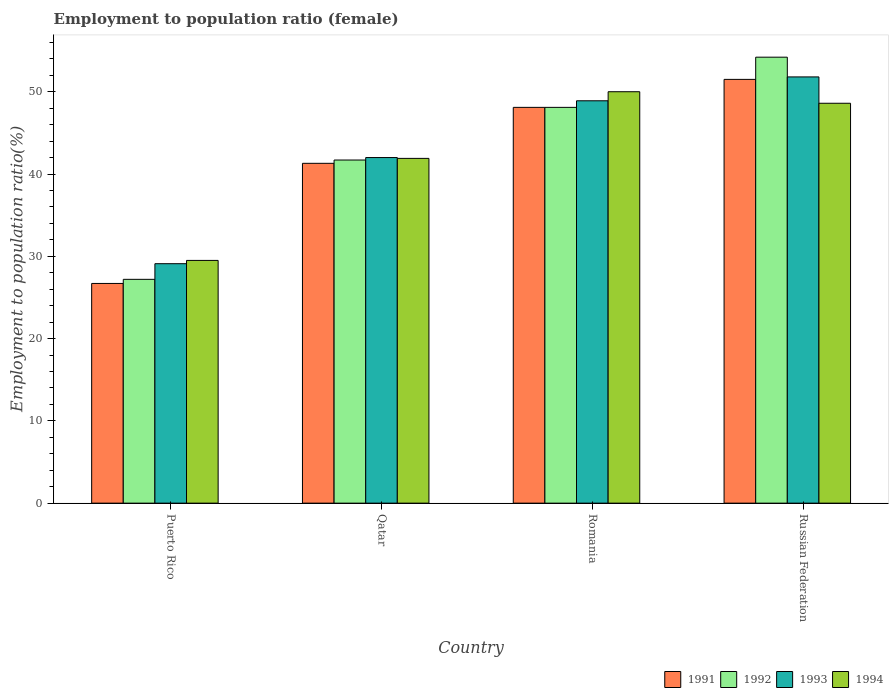How many groups of bars are there?
Your response must be concise. 4. Are the number of bars on each tick of the X-axis equal?
Ensure brevity in your answer.  Yes. How many bars are there on the 4th tick from the left?
Make the answer very short. 4. How many bars are there on the 1st tick from the right?
Offer a very short reply. 4. What is the label of the 2nd group of bars from the left?
Your answer should be compact. Qatar. What is the employment to population ratio in 1991 in Puerto Rico?
Keep it short and to the point. 26.7. Across all countries, what is the maximum employment to population ratio in 1991?
Offer a very short reply. 51.5. Across all countries, what is the minimum employment to population ratio in 1992?
Your answer should be very brief. 27.2. In which country was the employment to population ratio in 1994 maximum?
Offer a terse response. Romania. In which country was the employment to population ratio in 1994 minimum?
Your answer should be compact. Puerto Rico. What is the total employment to population ratio in 1992 in the graph?
Your response must be concise. 171.2. What is the difference between the employment to population ratio in 1991 in Romania and that in Russian Federation?
Provide a succinct answer. -3.4. What is the difference between the employment to population ratio in 1991 in Romania and the employment to population ratio in 1992 in Russian Federation?
Give a very brief answer. -6.1. What is the average employment to population ratio in 1992 per country?
Ensure brevity in your answer.  42.8. What is the difference between the employment to population ratio of/in 1994 and employment to population ratio of/in 1992 in Qatar?
Provide a succinct answer. 0.2. In how many countries, is the employment to population ratio in 1992 greater than 20 %?
Offer a terse response. 4. What is the ratio of the employment to population ratio in 1993 in Puerto Rico to that in Romania?
Offer a very short reply. 0.6. Is the employment to population ratio in 1993 in Puerto Rico less than that in Russian Federation?
Your answer should be very brief. Yes. Is the difference between the employment to population ratio in 1994 in Qatar and Russian Federation greater than the difference between the employment to population ratio in 1992 in Qatar and Russian Federation?
Offer a terse response. Yes. What is the difference between the highest and the second highest employment to population ratio in 1994?
Provide a succinct answer. 6.7. What is the difference between the highest and the lowest employment to population ratio in 1992?
Your answer should be very brief. 27. Is it the case that in every country, the sum of the employment to population ratio in 1991 and employment to population ratio in 1994 is greater than the sum of employment to population ratio in 1993 and employment to population ratio in 1992?
Your answer should be very brief. No. Is it the case that in every country, the sum of the employment to population ratio in 1994 and employment to population ratio in 1992 is greater than the employment to population ratio in 1991?
Keep it short and to the point. Yes. Are all the bars in the graph horizontal?
Your answer should be compact. No. What is the difference between two consecutive major ticks on the Y-axis?
Make the answer very short. 10. Does the graph contain grids?
Keep it short and to the point. No. Where does the legend appear in the graph?
Offer a very short reply. Bottom right. How many legend labels are there?
Keep it short and to the point. 4. How are the legend labels stacked?
Offer a very short reply. Horizontal. What is the title of the graph?
Provide a succinct answer. Employment to population ratio (female). Does "1960" appear as one of the legend labels in the graph?
Your answer should be compact. No. What is the Employment to population ratio(%) in 1991 in Puerto Rico?
Your response must be concise. 26.7. What is the Employment to population ratio(%) of 1992 in Puerto Rico?
Your response must be concise. 27.2. What is the Employment to population ratio(%) of 1993 in Puerto Rico?
Offer a terse response. 29.1. What is the Employment to population ratio(%) in 1994 in Puerto Rico?
Provide a short and direct response. 29.5. What is the Employment to population ratio(%) in 1991 in Qatar?
Keep it short and to the point. 41.3. What is the Employment to population ratio(%) in 1992 in Qatar?
Your response must be concise. 41.7. What is the Employment to population ratio(%) of 1994 in Qatar?
Keep it short and to the point. 41.9. What is the Employment to population ratio(%) in 1991 in Romania?
Your answer should be very brief. 48.1. What is the Employment to population ratio(%) of 1992 in Romania?
Give a very brief answer. 48.1. What is the Employment to population ratio(%) in 1993 in Romania?
Ensure brevity in your answer.  48.9. What is the Employment to population ratio(%) in 1994 in Romania?
Your answer should be very brief. 50. What is the Employment to population ratio(%) of 1991 in Russian Federation?
Offer a very short reply. 51.5. What is the Employment to population ratio(%) of 1992 in Russian Federation?
Keep it short and to the point. 54.2. What is the Employment to population ratio(%) in 1993 in Russian Federation?
Offer a terse response. 51.8. What is the Employment to population ratio(%) of 1994 in Russian Federation?
Keep it short and to the point. 48.6. Across all countries, what is the maximum Employment to population ratio(%) in 1991?
Provide a succinct answer. 51.5. Across all countries, what is the maximum Employment to population ratio(%) of 1992?
Provide a succinct answer. 54.2. Across all countries, what is the maximum Employment to population ratio(%) in 1993?
Provide a short and direct response. 51.8. Across all countries, what is the maximum Employment to population ratio(%) of 1994?
Give a very brief answer. 50. Across all countries, what is the minimum Employment to population ratio(%) of 1991?
Your answer should be compact. 26.7. Across all countries, what is the minimum Employment to population ratio(%) of 1992?
Provide a short and direct response. 27.2. Across all countries, what is the minimum Employment to population ratio(%) in 1993?
Offer a terse response. 29.1. Across all countries, what is the minimum Employment to population ratio(%) of 1994?
Offer a very short reply. 29.5. What is the total Employment to population ratio(%) in 1991 in the graph?
Make the answer very short. 167.6. What is the total Employment to population ratio(%) of 1992 in the graph?
Offer a very short reply. 171.2. What is the total Employment to population ratio(%) of 1993 in the graph?
Provide a short and direct response. 171.8. What is the total Employment to population ratio(%) in 1994 in the graph?
Offer a terse response. 170. What is the difference between the Employment to population ratio(%) in 1991 in Puerto Rico and that in Qatar?
Your answer should be very brief. -14.6. What is the difference between the Employment to population ratio(%) of 1994 in Puerto Rico and that in Qatar?
Your answer should be very brief. -12.4. What is the difference between the Employment to population ratio(%) in 1991 in Puerto Rico and that in Romania?
Your response must be concise. -21.4. What is the difference between the Employment to population ratio(%) in 1992 in Puerto Rico and that in Romania?
Provide a succinct answer. -20.9. What is the difference between the Employment to population ratio(%) in 1993 in Puerto Rico and that in Romania?
Provide a short and direct response. -19.8. What is the difference between the Employment to population ratio(%) of 1994 in Puerto Rico and that in Romania?
Give a very brief answer. -20.5. What is the difference between the Employment to population ratio(%) in 1991 in Puerto Rico and that in Russian Federation?
Offer a terse response. -24.8. What is the difference between the Employment to population ratio(%) of 1992 in Puerto Rico and that in Russian Federation?
Offer a terse response. -27. What is the difference between the Employment to population ratio(%) in 1993 in Puerto Rico and that in Russian Federation?
Provide a succinct answer. -22.7. What is the difference between the Employment to population ratio(%) in 1994 in Puerto Rico and that in Russian Federation?
Your response must be concise. -19.1. What is the difference between the Employment to population ratio(%) of 1991 in Qatar and that in Romania?
Give a very brief answer. -6.8. What is the difference between the Employment to population ratio(%) in 1993 in Qatar and that in Romania?
Make the answer very short. -6.9. What is the difference between the Employment to population ratio(%) in 1994 in Qatar and that in Romania?
Provide a short and direct response. -8.1. What is the difference between the Employment to population ratio(%) of 1991 in Qatar and that in Russian Federation?
Your answer should be compact. -10.2. What is the difference between the Employment to population ratio(%) of 1992 in Qatar and that in Russian Federation?
Ensure brevity in your answer.  -12.5. What is the difference between the Employment to population ratio(%) of 1993 in Qatar and that in Russian Federation?
Offer a very short reply. -9.8. What is the difference between the Employment to population ratio(%) in 1993 in Romania and that in Russian Federation?
Keep it short and to the point. -2.9. What is the difference between the Employment to population ratio(%) in 1994 in Romania and that in Russian Federation?
Your answer should be very brief. 1.4. What is the difference between the Employment to population ratio(%) of 1991 in Puerto Rico and the Employment to population ratio(%) of 1993 in Qatar?
Your answer should be compact. -15.3. What is the difference between the Employment to population ratio(%) in 1991 in Puerto Rico and the Employment to population ratio(%) in 1994 in Qatar?
Your answer should be compact. -15.2. What is the difference between the Employment to population ratio(%) in 1992 in Puerto Rico and the Employment to population ratio(%) in 1993 in Qatar?
Offer a very short reply. -14.8. What is the difference between the Employment to population ratio(%) of 1992 in Puerto Rico and the Employment to population ratio(%) of 1994 in Qatar?
Your answer should be very brief. -14.7. What is the difference between the Employment to population ratio(%) of 1991 in Puerto Rico and the Employment to population ratio(%) of 1992 in Romania?
Ensure brevity in your answer.  -21.4. What is the difference between the Employment to population ratio(%) in 1991 in Puerto Rico and the Employment to population ratio(%) in 1993 in Romania?
Give a very brief answer. -22.2. What is the difference between the Employment to population ratio(%) of 1991 in Puerto Rico and the Employment to population ratio(%) of 1994 in Romania?
Offer a very short reply. -23.3. What is the difference between the Employment to population ratio(%) of 1992 in Puerto Rico and the Employment to population ratio(%) of 1993 in Romania?
Ensure brevity in your answer.  -21.7. What is the difference between the Employment to population ratio(%) in 1992 in Puerto Rico and the Employment to population ratio(%) in 1994 in Romania?
Offer a terse response. -22.8. What is the difference between the Employment to population ratio(%) of 1993 in Puerto Rico and the Employment to population ratio(%) of 1994 in Romania?
Offer a terse response. -20.9. What is the difference between the Employment to population ratio(%) in 1991 in Puerto Rico and the Employment to population ratio(%) in 1992 in Russian Federation?
Ensure brevity in your answer.  -27.5. What is the difference between the Employment to population ratio(%) of 1991 in Puerto Rico and the Employment to population ratio(%) of 1993 in Russian Federation?
Keep it short and to the point. -25.1. What is the difference between the Employment to population ratio(%) in 1991 in Puerto Rico and the Employment to population ratio(%) in 1994 in Russian Federation?
Make the answer very short. -21.9. What is the difference between the Employment to population ratio(%) in 1992 in Puerto Rico and the Employment to population ratio(%) in 1993 in Russian Federation?
Your response must be concise. -24.6. What is the difference between the Employment to population ratio(%) of 1992 in Puerto Rico and the Employment to population ratio(%) of 1994 in Russian Federation?
Your answer should be very brief. -21.4. What is the difference between the Employment to population ratio(%) in 1993 in Puerto Rico and the Employment to population ratio(%) in 1994 in Russian Federation?
Offer a very short reply. -19.5. What is the difference between the Employment to population ratio(%) in 1991 in Qatar and the Employment to population ratio(%) in 1992 in Romania?
Your answer should be very brief. -6.8. What is the difference between the Employment to population ratio(%) of 1991 in Qatar and the Employment to population ratio(%) of 1994 in Romania?
Make the answer very short. -8.7. What is the difference between the Employment to population ratio(%) of 1992 in Qatar and the Employment to population ratio(%) of 1993 in Romania?
Give a very brief answer. -7.2. What is the difference between the Employment to population ratio(%) of 1993 in Qatar and the Employment to population ratio(%) of 1994 in Romania?
Your response must be concise. -8. What is the difference between the Employment to population ratio(%) of 1991 in Qatar and the Employment to population ratio(%) of 1993 in Russian Federation?
Offer a very short reply. -10.5. What is the difference between the Employment to population ratio(%) in 1992 in Qatar and the Employment to population ratio(%) in 1993 in Russian Federation?
Offer a very short reply. -10.1. What is the difference between the Employment to population ratio(%) of 1992 in Qatar and the Employment to population ratio(%) of 1994 in Russian Federation?
Provide a succinct answer. -6.9. What is the difference between the Employment to population ratio(%) of 1991 in Romania and the Employment to population ratio(%) of 1993 in Russian Federation?
Keep it short and to the point. -3.7. What is the difference between the Employment to population ratio(%) in 1991 in Romania and the Employment to population ratio(%) in 1994 in Russian Federation?
Offer a terse response. -0.5. What is the difference between the Employment to population ratio(%) of 1992 in Romania and the Employment to population ratio(%) of 1993 in Russian Federation?
Provide a short and direct response. -3.7. What is the difference between the Employment to population ratio(%) of 1992 in Romania and the Employment to population ratio(%) of 1994 in Russian Federation?
Provide a short and direct response. -0.5. What is the average Employment to population ratio(%) in 1991 per country?
Give a very brief answer. 41.9. What is the average Employment to population ratio(%) in 1992 per country?
Offer a very short reply. 42.8. What is the average Employment to population ratio(%) in 1993 per country?
Offer a very short reply. 42.95. What is the average Employment to population ratio(%) in 1994 per country?
Ensure brevity in your answer.  42.5. What is the difference between the Employment to population ratio(%) of 1991 and Employment to population ratio(%) of 1992 in Puerto Rico?
Your answer should be compact. -0.5. What is the difference between the Employment to population ratio(%) of 1991 and Employment to population ratio(%) of 1993 in Puerto Rico?
Your answer should be very brief. -2.4. What is the difference between the Employment to population ratio(%) in 1991 and Employment to population ratio(%) in 1994 in Puerto Rico?
Provide a short and direct response. -2.8. What is the difference between the Employment to population ratio(%) in 1992 and Employment to population ratio(%) in 1993 in Puerto Rico?
Keep it short and to the point. -1.9. What is the difference between the Employment to population ratio(%) of 1992 and Employment to population ratio(%) of 1994 in Puerto Rico?
Provide a succinct answer. -2.3. What is the difference between the Employment to population ratio(%) of 1993 and Employment to population ratio(%) of 1994 in Puerto Rico?
Keep it short and to the point. -0.4. What is the difference between the Employment to population ratio(%) in 1991 and Employment to population ratio(%) in 1993 in Qatar?
Your answer should be compact. -0.7. What is the difference between the Employment to population ratio(%) in 1992 and Employment to population ratio(%) in 1993 in Qatar?
Offer a very short reply. -0.3. What is the difference between the Employment to population ratio(%) of 1992 and Employment to population ratio(%) of 1994 in Qatar?
Your response must be concise. -0.2. What is the difference between the Employment to population ratio(%) in 1991 and Employment to population ratio(%) in 1992 in Romania?
Your answer should be compact. 0. What is the difference between the Employment to population ratio(%) in 1991 and Employment to population ratio(%) in 1994 in Romania?
Provide a short and direct response. -1.9. What is the difference between the Employment to population ratio(%) in 1992 and Employment to population ratio(%) in 1994 in Romania?
Give a very brief answer. -1.9. What is the difference between the Employment to population ratio(%) in 1991 and Employment to population ratio(%) in 1992 in Russian Federation?
Provide a short and direct response. -2.7. What is the difference between the Employment to population ratio(%) of 1991 and Employment to population ratio(%) of 1993 in Russian Federation?
Offer a very short reply. -0.3. What is the difference between the Employment to population ratio(%) in 1992 and Employment to population ratio(%) in 1994 in Russian Federation?
Make the answer very short. 5.6. What is the difference between the Employment to population ratio(%) in 1993 and Employment to population ratio(%) in 1994 in Russian Federation?
Your response must be concise. 3.2. What is the ratio of the Employment to population ratio(%) in 1991 in Puerto Rico to that in Qatar?
Your response must be concise. 0.65. What is the ratio of the Employment to population ratio(%) of 1992 in Puerto Rico to that in Qatar?
Your answer should be very brief. 0.65. What is the ratio of the Employment to population ratio(%) of 1993 in Puerto Rico to that in Qatar?
Give a very brief answer. 0.69. What is the ratio of the Employment to population ratio(%) of 1994 in Puerto Rico to that in Qatar?
Give a very brief answer. 0.7. What is the ratio of the Employment to population ratio(%) in 1991 in Puerto Rico to that in Romania?
Offer a terse response. 0.56. What is the ratio of the Employment to population ratio(%) in 1992 in Puerto Rico to that in Romania?
Your answer should be very brief. 0.57. What is the ratio of the Employment to population ratio(%) in 1993 in Puerto Rico to that in Romania?
Make the answer very short. 0.6. What is the ratio of the Employment to population ratio(%) in 1994 in Puerto Rico to that in Romania?
Offer a very short reply. 0.59. What is the ratio of the Employment to population ratio(%) in 1991 in Puerto Rico to that in Russian Federation?
Your answer should be compact. 0.52. What is the ratio of the Employment to population ratio(%) in 1992 in Puerto Rico to that in Russian Federation?
Your answer should be compact. 0.5. What is the ratio of the Employment to population ratio(%) in 1993 in Puerto Rico to that in Russian Federation?
Ensure brevity in your answer.  0.56. What is the ratio of the Employment to population ratio(%) of 1994 in Puerto Rico to that in Russian Federation?
Offer a very short reply. 0.61. What is the ratio of the Employment to population ratio(%) of 1991 in Qatar to that in Romania?
Keep it short and to the point. 0.86. What is the ratio of the Employment to population ratio(%) of 1992 in Qatar to that in Romania?
Your answer should be compact. 0.87. What is the ratio of the Employment to population ratio(%) in 1993 in Qatar to that in Romania?
Your answer should be very brief. 0.86. What is the ratio of the Employment to population ratio(%) of 1994 in Qatar to that in Romania?
Offer a terse response. 0.84. What is the ratio of the Employment to population ratio(%) of 1991 in Qatar to that in Russian Federation?
Ensure brevity in your answer.  0.8. What is the ratio of the Employment to population ratio(%) in 1992 in Qatar to that in Russian Federation?
Offer a terse response. 0.77. What is the ratio of the Employment to population ratio(%) of 1993 in Qatar to that in Russian Federation?
Ensure brevity in your answer.  0.81. What is the ratio of the Employment to population ratio(%) of 1994 in Qatar to that in Russian Federation?
Your answer should be very brief. 0.86. What is the ratio of the Employment to population ratio(%) of 1991 in Romania to that in Russian Federation?
Your response must be concise. 0.93. What is the ratio of the Employment to population ratio(%) in 1992 in Romania to that in Russian Federation?
Provide a short and direct response. 0.89. What is the ratio of the Employment to population ratio(%) of 1993 in Romania to that in Russian Federation?
Provide a short and direct response. 0.94. What is the ratio of the Employment to population ratio(%) in 1994 in Romania to that in Russian Federation?
Keep it short and to the point. 1.03. What is the difference between the highest and the second highest Employment to population ratio(%) of 1991?
Give a very brief answer. 3.4. What is the difference between the highest and the second highest Employment to population ratio(%) of 1992?
Offer a terse response. 6.1. What is the difference between the highest and the second highest Employment to population ratio(%) in 1994?
Your answer should be very brief. 1.4. What is the difference between the highest and the lowest Employment to population ratio(%) of 1991?
Ensure brevity in your answer.  24.8. What is the difference between the highest and the lowest Employment to population ratio(%) in 1992?
Offer a very short reply. 27. What is the difference between the highest and the lowest Employment to population ratio(%) in 1993?
Offer a very short reply. 22.7. What is the difference between the highest and the lowest Employment to population ratio(%) in 1994?
Your response must be concise. 20.5. 